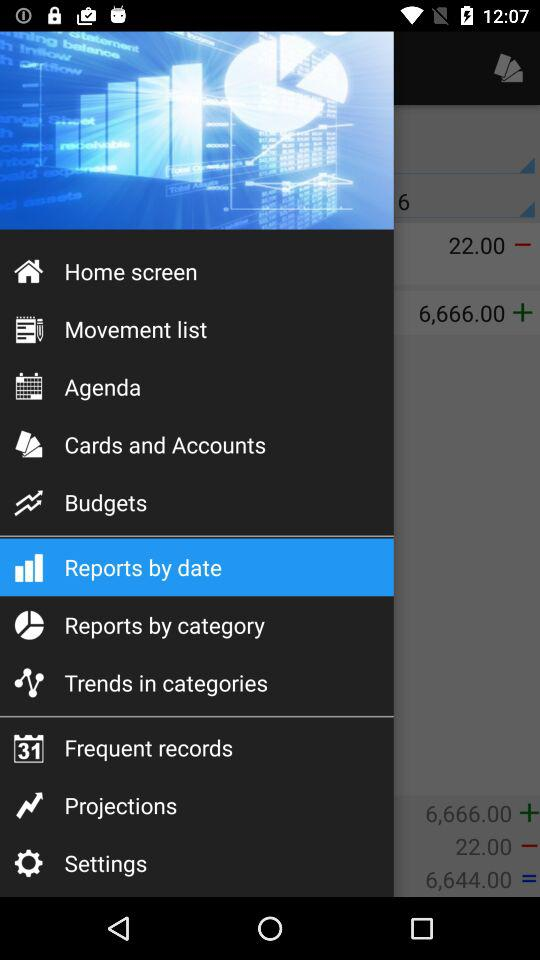What is the total amount of money in the account?
Answer the question using a single word or phrase. 6,644.00 